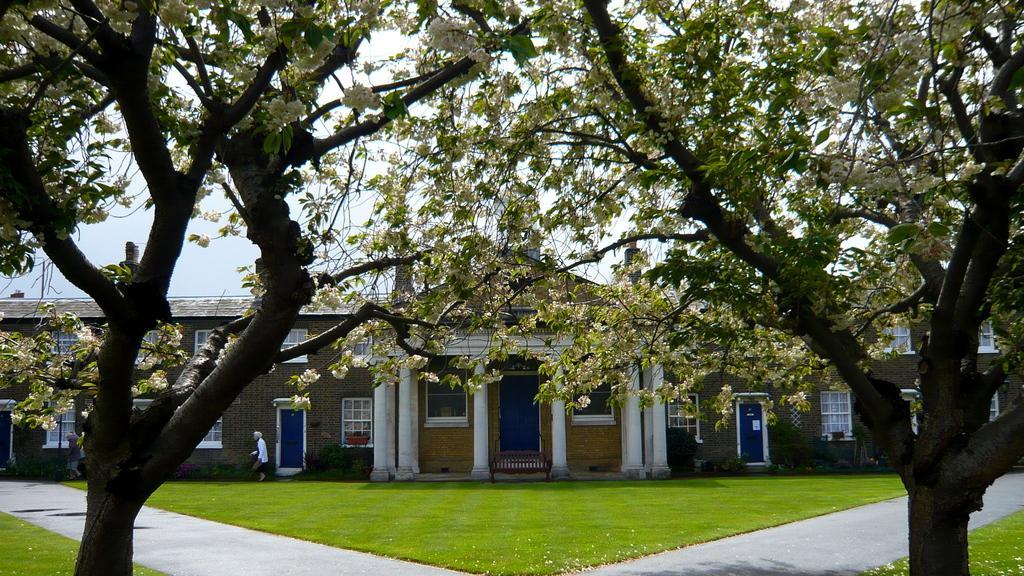Could you give a brief overview of what you see in this image? In the picture I can see a building, the grass, trees and people walking on the ground. In the background I can see the sky. 